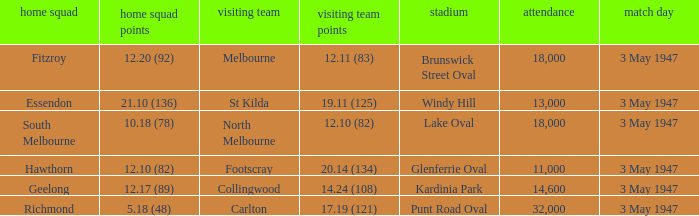Which venue did the away team score 12.10 (82)? Lake Oval. 